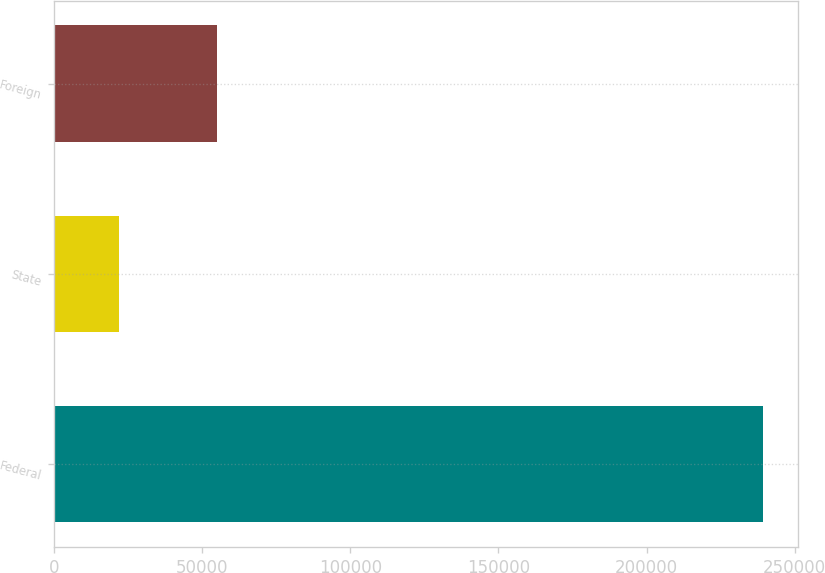Convert chart to OTSL. <chart><loc_0><loc_0><loc_500><loc_500><bar_chart><fcel>Federal<fcel>State<fcel>Foreign<nl><fcel>239217<fcel>21779<fcel>54937<nl></chart> 